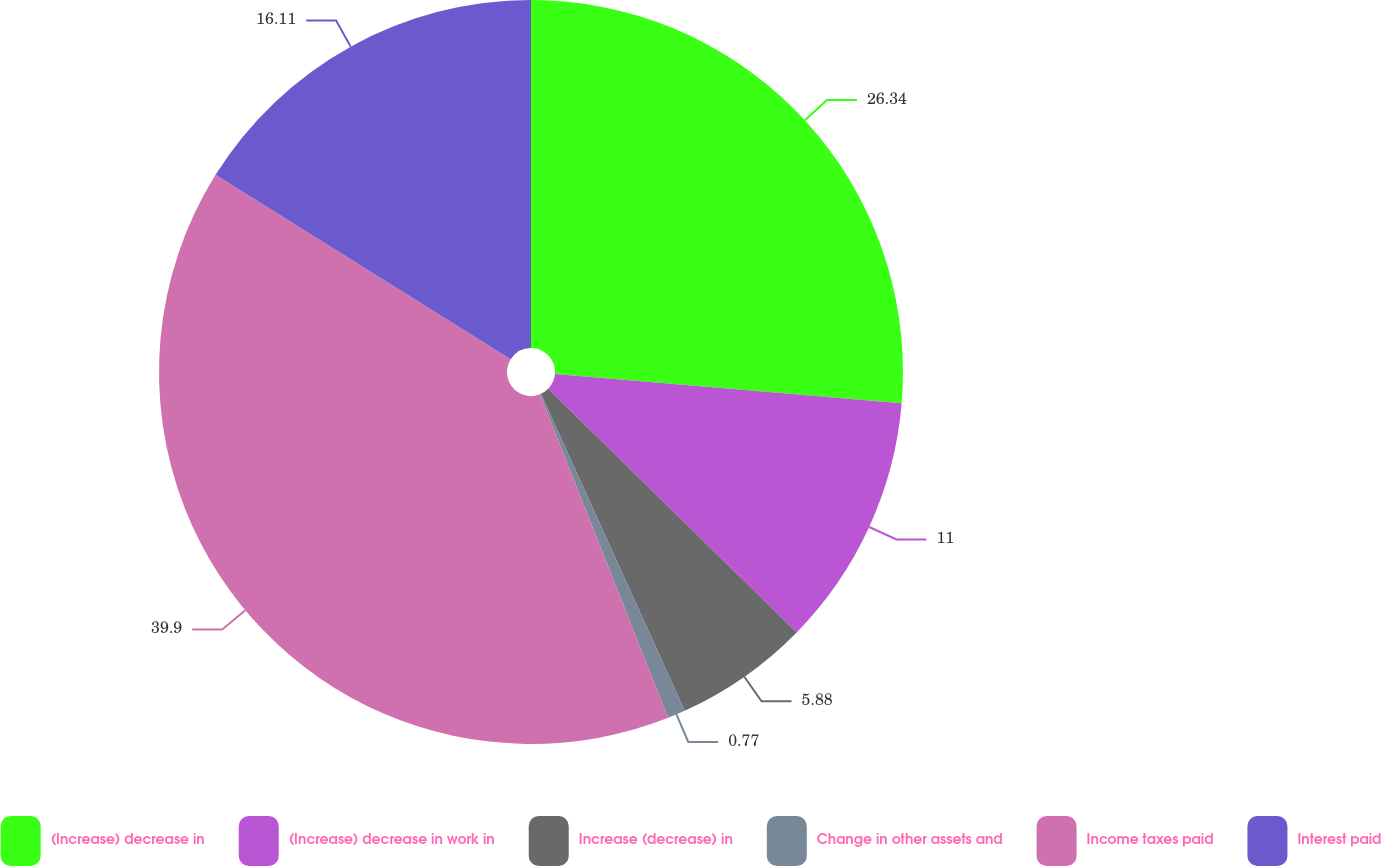<chart> <loc_0><loc_0><loc_500><loc_500><pie_chart><fcel>(Increase) decrease in<fcel>(Increase) decrease in work in<fcel>Increase (decrease) in<fcel>Change in other assets and<fcel>Income taxes paid<fcel>Interest paid<nl><fcel>26.34%<fcel>11.0%<fcel>5.88%<fcel>0.77%<fcel>39.9%<fcel>16.11%<nl></chart> 